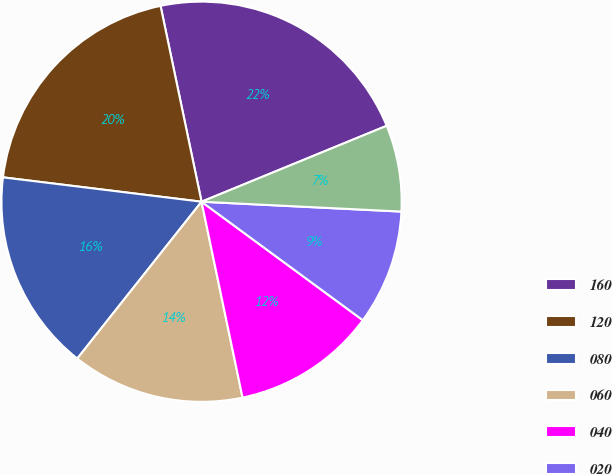<chart> <loc_0><loc_0><loc_500><loc_500><pie_chart><fcel>160<fcel>120<fcel>080<fcel>060<fcel>040<fcel>020<fcel>010<nl><fcel>22.09%<fcel>19.77%<fcel>16.28%<fcel>13.95%<fcel>11.63%<fcel>9.3%<fcel>6.98%<nl></chart> 